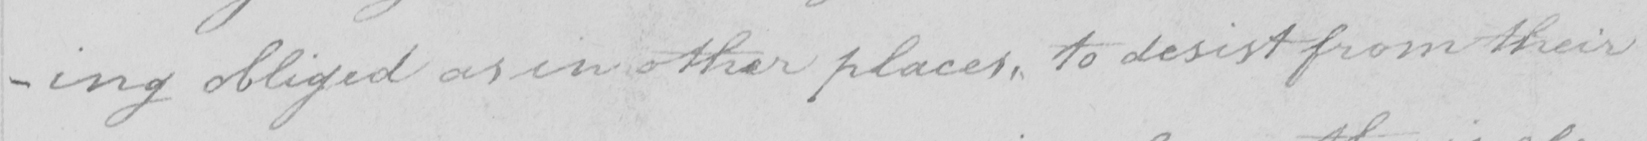What text is written in this handwritten line? -ing obliged as in other places , to desist from their 